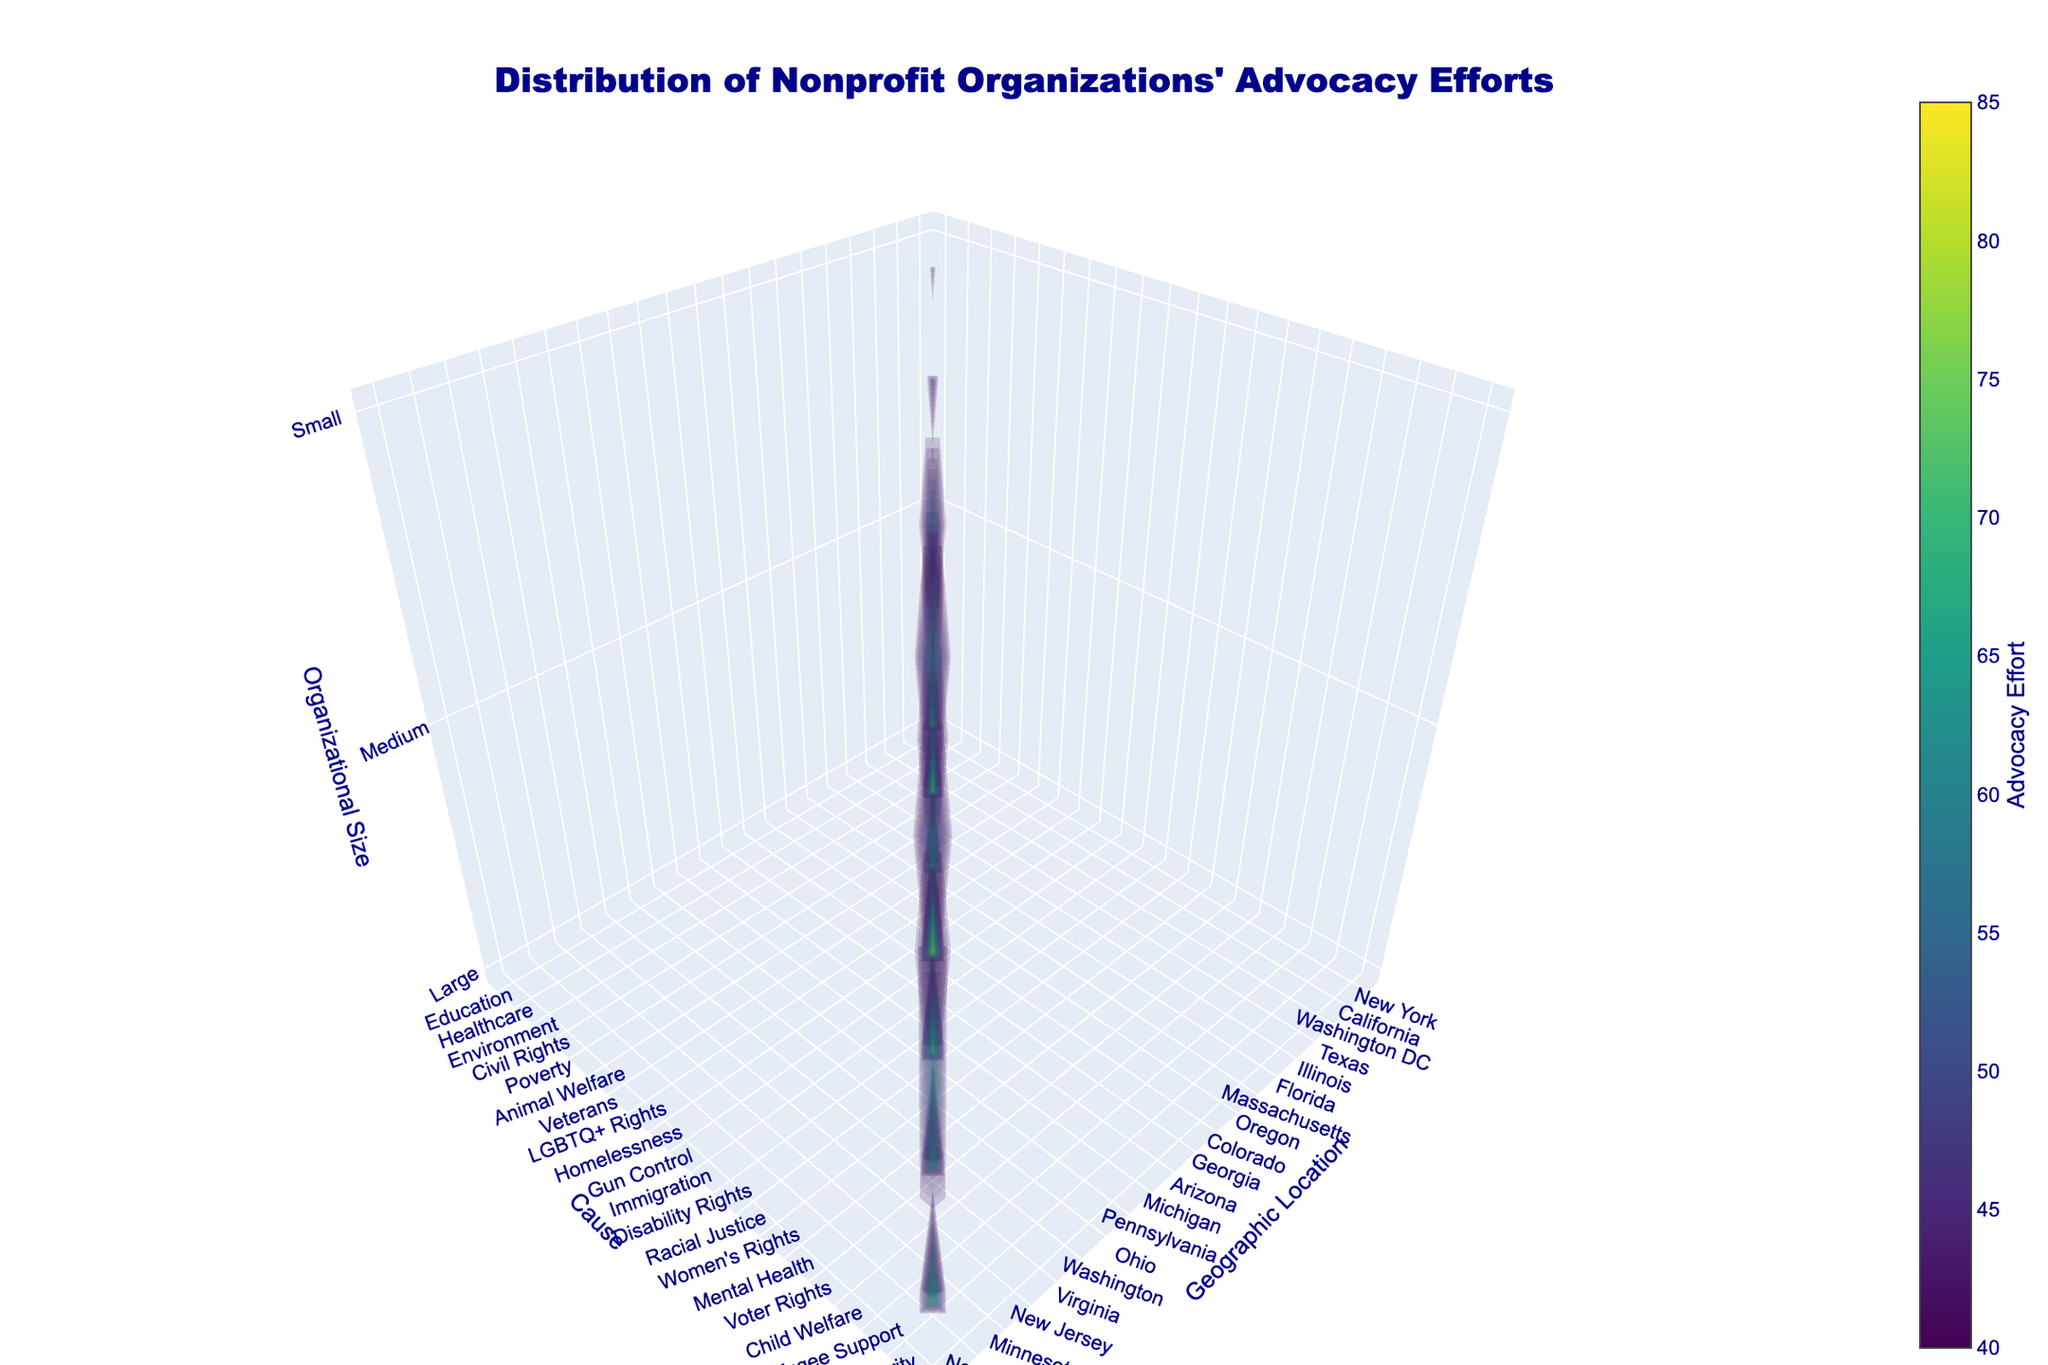What's the title of the figure? The title is usually placed at the top of the figure and provides a brief description of the contents. Here, it reads "Distribution of Nonprofit Organizations' Advocacy Efforts".
Answer: Distribution of Nonprofit Organizations' Advocacy Efforts What does the x-axis represent? The x-axis typically represents a variable, and the label under the x-axis shows that this axis represents "Geographic Location".
Answer: Geographic Location What is the range for the Advocacy Effort values shown on the color scale? The color scale is found alongside the figure and shows the minimum and maximum values it represents, which are labeled as 40 and 85.
Answer: 40 to 85 Which cause has the highest advocacy effort for large organizations? To find this, look for the highest value on the z-axis (which represents large organizations) and see which cause corresponds to it. It occurs at a high point in "Gun Control" with a value of 85.
Answer: Gun Control Compare the advocacy efforts for small and medium-sized organizations in Washington DC for Environmental causes. Which is higher? By observing the volume plot for Washington DC under the Environmental cause, you can compare the height values of the small and medium-sized organizations. The medium-sized organizations have higher advocacy efforts compared to small ones (60 vs. 45, as seen on the z-axis).
Answer: Medium-sized organizations What color primarily represents the regions with the lowest advocacy effort? Lower advocacy efforts as suggested by the color scale would be represented by colors at the start of the scale. Observing the plot, the darker colors, like dark blue, represent lower values.
Answer: Dark blue What's the overall advocacy effort for large and medium-sized organizations in Texas for civil rights? Since large organizations in Texas have an advocacy effort of 80 and medium-sized ones are not shown there, the sum is equal to only the large organizational effort, as 0 for mediums.
Answer: 80 Compare California and Pennsylvania for medium-sized organizations. Which has a higher average advocacy effort? Medium-sized organizations in California show a value of 60, while those in Pennsylvania show 0 (no data point for medium in Pennsylvania’s section). Hence, California is higher.
Answer: California What is the average advocacy effort for medium-sized organizations across all causes? Identify the medium-sized organizations’ values, then calculate the mean: (60 + 55 + 65 + 58 + 62 + 57 + 68) / 7 resulting in 60.71.
Answer: 60.71 For small organizations focusing on Disability Rights in Michigan, what is their advocacy effort, and how does it compare with other causes in the same state? Small organizations in Michigan for Disability Rights have an advocacy effort of 42, one would need to compare visually with other points in the same state but different causes (which are absent in this dataset).
Answer: 42 